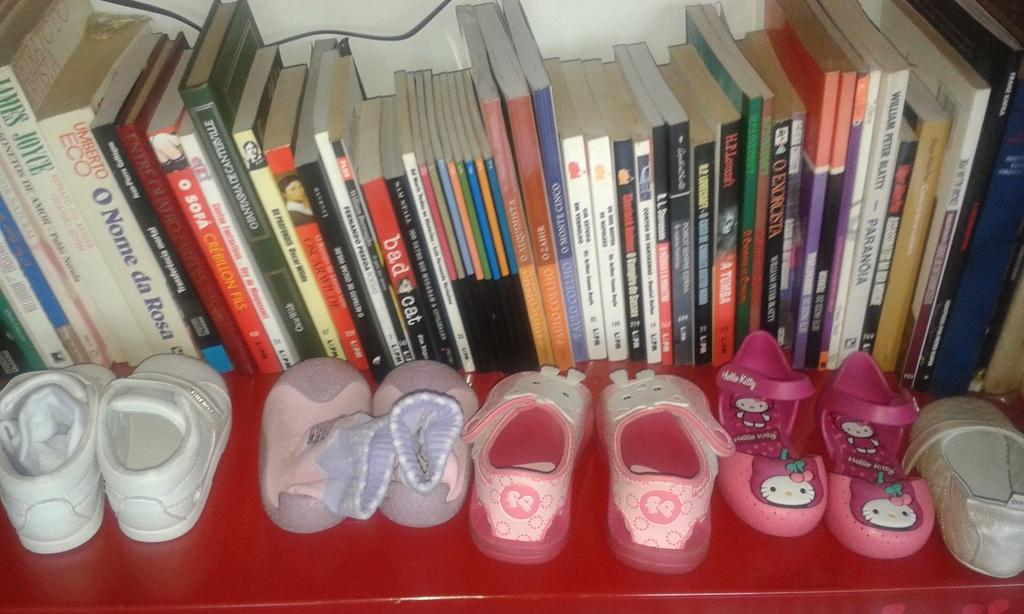What objects are arranged in a row in the image? There are books placed in a row in the image. Where are the books located in the image? The books are at the top of the image. What type of footwear can be seen in the image? There are shoes with different colors in the image. Where are the shoes located in the image? The shoes are at the bottom of the image. What type of border is visible around the image? There is no border visible around the image. Can you describe the girl in the image? There is no girl present in the image. 